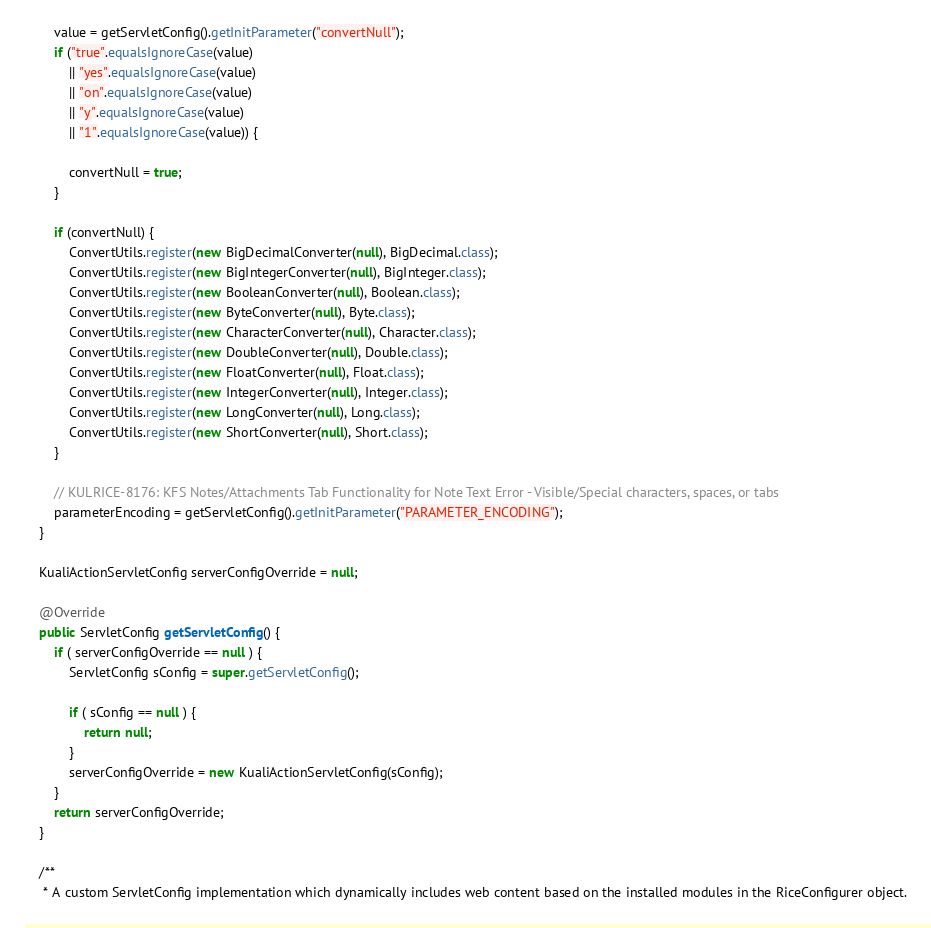Convert code to text. <code><loc_0><loc_0><loc_500><loc_500><_Java_>        value = getServletConfig().getInitParameter("convertNull");
        if ("true".equalsIgnoreCase(value)
            || "yes".equalsIgnoreCase(value)
            || "on".equalsIgnoreCase(value)
            || "y".equalsIgnoreCase(value)
            || "1".equalsIgnoreCase(value)) {

            convertNull = true;
        }

        if (convertNull) {
            ConvertUtils.register(new BigDecimalConverter(null), BigDecimal.class);
            ConvertUtils.register(new BigIntegerConverter(null), BigInteger.class);
            ConvertUtils.register(new BooleanConverter(null), Boolean.class);
            ConvertUtils.register(new ByteConverter(null), Byte.class);
            ConvertUtils.register(new CharacterConverter(null), Character.class);
            ConvertUtils.register(new DoubleConverter(null), Double.class);
            ConvertUtils.register(new FloatConverter(null), Float.class);
            ConvertUtils.register(new IntegerConverter(null), Integer.class);
            ConvertUtils.register(new LongConverter(null), Long.class);
            ConvertUtils.register(new ShortConverter(null), Short.class);
        }

        // KULRICE-8176: KFS Notes/Attachments Tab Functionality for Note Text Error - Visible/Special characters, spaces, or tabs
        parameterEncoding = getServletConfig().getInitParameter("PARAMETER_ENCODING");
    }

    KualiActionServletConfig serverConfigOverride = null;

    @Override
    public ServletConfig getServletConfig() {
        if ( serverConfigOverride == null ) {
            ServletConfig sConfig = super.getServletConfig();

            if ( sConfig == null ) {
                return null;
            }
            serverConfigOverride = new KualiActionServletConfig(sConfig);
        }
        return serverConfigOverride;
    }

    /**
     * A custom ServletConfig implementation which dynamically includes web content based on the installed modules in the RiceConfigurer object.</code> 